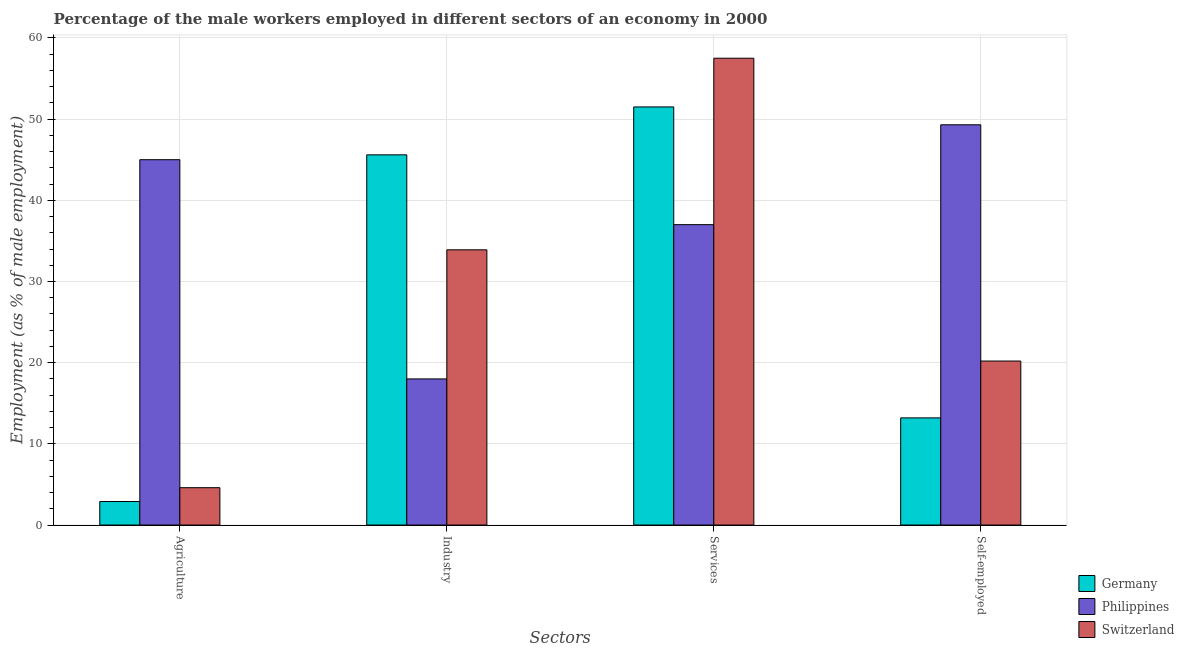How many different coloured bars are there?
Offer a terse response. 3. How many groups of bars are there?
Make the answer very short. 4. Are the number of bars per tick equal to the number of legend labels?
Your answer should be very brief. Yes. Are the number of bars on each tick of the X-axis equal?
Provide a short and direct response. Yes. How many bars are there on the 4th tick from the right?
Keep it short and to the point. 3. What is the label of the 2nd group of bars from the left?
Offer a very short reply. Industry. What is the percentage of male workers in services in Switzerland?
Your response must be concise. 57.5. Across all countries, what is the maximum percentage of male workers in industry?
Your response must be concise. 45.6. Across all countries, what is the minimum percentage of male workers in agriculture?
Offer a terse response. 2.9. In which country was the percentage of male workers in services maximum?
Your response must be concise. Switzerland. What is the total percentage of self employed male workers in the graph?
Offer a very short reply. 82.7. What is the difference between the percentage of male workers in agriculture in Germany and that in Philippines?
Give a very brief answer. -42.1. What is the difference between the percentage of male workers in industry in Germany and the percentage of self employed male workers in Philippines?
Your answer should be compact. -3.7. What is the ratio of the percentage of male workers in agriculture in Germany to that in Philippines?
Offer a very short reply. 0.06. What is the difference between the highest and the second highest percentage of male workers in agriculture?
Give a very brief answer. 40.4. What is the difference between the highest and the lowest percentage of male workers in industry?
Offer a terse response. 27.6. What does the 3rd bar from the left in Services represents?
Ensure brevity in your answer.  Switzerland. What does the 1st bar from the right in Industry represents?
Give a very brief answer. Switzerland. Is it the case that in every country, the sum of the percentage of male workers in agriculture and percentage of male workers in industry is greater than the percentage of male workers in services?
Provide a short and direct response. No. How many bars are there?
Offer a terse response. 12. Are all the bars in the graph horizontal?
Provide a short and direct response. No. How many countries are there in the graph?
Give a very brief answer. 3. What is the difference between two consecutive major ticks on the Y-axis?
Give a very brief answer. 10. Are the values on the major ticks of Y-axis written in scientific E-notation?
Keep it short and to the point. No. How many legend labels are there?
Make the answer very short. 3. How are the legend labels stacked?
Ensure brevity in your answer.  Vertical. What is the title of the graph?
Your answer should be very brief. Percentage of the male workers employed in different sectors of an economy in 2000. What is the label or title of the X-axis?
Your answer should be very brief. Sectors. What is the label or title of the Y-axis?
Make the answer very short. Employment (as % of male employment). What is the Employment (as % of male employment) of Germany in Agriculture?
Offer a terse response. 2.9. What is the Employment (as % of male employment) of Philippines in Agriculture?
Your response must be concise. 45. What is the Employment (as % of male employment) of Switzerland in Agriculture?
Offer a very short reply. 4.6. What is the Employment (as % of male employment) of Germany in Industry?
Make the answer very short. 45.6. What is the Employment (as % of male employment) in Philippines in Industry?
Offer a terse response. 18. What is the Employment (as % of male employment) in Switzerland in Industry?
Offer a very short reply. 33.9. What is the Employment (as % of male employment) of Germany in Services?
Provide a succinct answer. 51.5. What is the Employment (as % of male employment) of Philippines in Services?
Give a very brief answer. 37. What is the Employment (as % of male employment) in Switzerland in Services?
Give a very brief answer. 57.5. What is the Employment (as % of male employment) of Germany in Self-employed?
Your response must be concise. 13.2. What is the Employment (as % of male employment) in Philippines in Self-employed?
Your answer should be compact. 49.3. What is the Employment (as % of male employment) of Switzerland in Self-employed?
Ensure brevity in your answer.  20.2. Across all Sectors, what is the maximum Employment (as % of male employment) in Germany?
Offer a terse response. 51.5. Across all Sectors, what is the maximum Employment (as % of male employment) in Philippines?
Offer a very short reply. 49.3. Across all Sectors, what is the maximum Employment (as % of male employment) of Switzerland?
Make the answer very short. 57.5. Across all Sectors, what is the minimum Employment (as % of male employment) of Germany?
Offer a terse response. 2.9. Across all Sectors, what is the minimum Employment (as % of male employment) of Philippines?
Your answer should be compact. 18. Across all Sectors, what is the minimum Employment (as % of male employment) in Switzerland?
Your response must be concise. 4.6. What is the total Employment (as % of male employment) in Germany in the graph?
Keep it short and to the point. 113.2. What is the total Employment (as % of male employment) of Philippines in the graph?
Provide a succinct answer. 149.3. What is the total Employment (as % of male employment) in Switzerland in the graph?
Your answer should be compact. 116.2. What is the difference between the Employment (as % of male employment) in Germany in Agriculture and that in Industry?
Provide a succinct answer. -42.7. What is the difference between the Employment (as % of male employment) in Philippines in Agriculture and that in Industry?
Offer a terse response. 27. What is the difference between the Employment (as % of male employment) of Switzerland in Agriculture and that in Industry?
Your answer should be compact. -29.3. What is the difference between the Employment (as % of male employment) in Germany in Agriculture and that in Services?
Make the answer very short. -48.6. What is the difference between the Employment (as % of male employment) in Philippines in Agriculture and that in Services?
Give a very brief answer. 8. What is the difference between the Employment (as % of male employment) of Switzerland in Agriculture and that in Services?
Your answer should be compact. -52.9. What is the difference between the Employment (as % of male employment) of Germany in Agriculture and that in Self-employed?
Offer a very short reply. -10.3. What is the difference between the Employment (as % of male employment) in Philippines in Agriculture and that in Self-employed?
Keep it short and to the point. -4.3. What is the difference between the Employment (as % of male employment) in Switzerland in Agriculture and that in Self-employed?
Keep it short and to the point. -15.6. What is the difference between the Employment (as % of male employment) of Switzerland in Industry and that in Services?
Keep it short and to the point. -23.6. What is the difference between the Employment (as % of male employment) in Germany in Industry and that in Self-employed?
Your answer should be very brief. 32.4. What is the difference between the Employment (as % of male employment) in Philippines in Industry and that in Self-employed?
Provide a succinct answer. -31.3. What is the difference between the Employment (as % of male employment) of Switzerland in Industry and that in Self-employed?
Make the answer very short. 13.7. What is the difference between the Employment (as % of male employment) in Germany in Services and that in Self-employed?
Provide a short and direct response. 38.3. What is the difference between the Employment (as % of male employment) in Philippines in Services and that in Self-employed?
Your answer should be very brief. -12.3. What is the difference between the Employment (as % of male employment) in Switzerland in Services and that in Self-employed?
Give a very brief answer. 37.3. What is the difference between the Employment (as % of male employment) of Germany in Agriculture and the Employment (as % of male employment) of Philippines in Industry?
Provide a short and direct response. -15.1. What is the difference between the Employment (as % of male employment) of Germany in Agriculture and the Employment (as % of male employment) of Switzerland in Industry?
Keep it short and to the point. -31. What is the difference between the Employment (as % of male employment) in Germany in Agriculture and the Employment (as % of male employment) in Philippines in Services?
Keep it short and to the point. -34.1. What is the difference between the Employment (as % of male employment) in Germany in Agriculture and the Employment (as % of male employment) in Switzerland in Services?
Ensure brevity in your answer.  -54.6. What is the difference between the Employment (as % of male employment) in Philippines in Agriculture and the Employment (as % of male employment) in Switzerland in Services?
Your answer should be compact. -12.5. What is the difference between the Employment (as % of male employment) of Germany in Agriculture and the Employment (as % of male employment) of Philippines in Self-employed?
Ensure brevity in your answer.  -46.4. What is the difference between the Employment (as % of male employment) of Germany in Agriculture and the Employment (as % of male employment) of Switzerland in Self-employed?
Your answer should be compact. -17.3. What is the difference between the Employment (as % of male employment) of Philippines in Agriculture and the Employment (as % of male employment) of Switzerland in Self-employed?
Provide a succinct answer. 24.8. What is the difference between the Employment (as % of male employment) in Germany in Industry and the Employment (as % of male employment) in Philippines in Services?
Your answer should be very brief. 8.6. What is the difference between the Employment (as % of male employment) in Philippines in Industry and the Employment (as % of male employment) in Switzerland in Services?
Give a very brief answer. -39.5. What is the difference between the Employment (as % of male employment) of Germany in Industry and the Employment (as % of male employment) of Switzerland in Self-employed?
Keep it short and to the point. 25.4. What is the difference between the Employment (as % of male employment) of Philippines in Industry and the Employment (as % of male employment) of Switzerland in Self-employed?
Offer a terse response. -2.2. What is the difference between the Employment (as % of male employment) in Germany in Services and the Employment (as % of male employment) in Philippines in Self-employed?
Ensure brevity in your answer.  2.2. What is the difference between the Employment (as % of male employment) in Germany in Services and the Employment (as % of male employment) in Switzerland in Self-employed?
Keep it short and to the point. 31.3. What is the average Employment (as % of male employment) in Germany per Sectors?
Your answer should be very brief. 28.3. What is the average Employment (as % of male employment) in Philippines per Sectors?
Give a very brief answer. 37.33. What is the average Employment (as % of male employment) of Switzerland per Sectors?
Make the answer very short. 29.05. What is the difference between the Employment (as % of male employment) in Germany and Employment (as % of male employment) in Philippines in Agriculture?
Make the answer very short. -42.1. What is the difference between the Employment (as % of male employment) in Philippines and Employment (as % of male employment) in Switzerland in Agriculture?
Your answer should be compact. 40.4. What is the difference between the Employment (as % of male employment) in Germany and Employment (as % of male employment) in Philippines in Industry?
Give a very brief answer. 27.6. What is the difference between the Employment (as % of male employment) of Philippines and Employment (as % of male employment) of Switzerland in Industry?
Offer a very short reply. -15.9. What is the difference between the Employment (as % of male employment) of Germany and Employment (as % of male employment) of Philippines in Services?
Offer a terse response. 14.5. What is the difference between the Employment (as % of male employment) in Philippines and Employment (as % of male employment) in Switzerland in Services?
Your response must be concise. -20.5. What is the difference between the Employment (as % of male employment) in Germany and Employment (as % of male employment) in Philippines in Self-employed?
Your response must be concise. -36.1. What is the difference between the Employment (as % of male employment) in Germany and Employment (as % of male employment) in Switzerland in Self-employed?
Provide a short and direct response. -7. What is the difference between the Employment (as % of male employment) in Philippines and Employment (as % of male employment) in Switzerland in Self-employed?
Offer a terse response. 29.1. What is the ratio of the Employment (as % of male employment) of Germany in Agriculture to that in Industry?
Make the answer very short. 0.06. What is the ratio of the Employment (as % of male employment) of Switzerland in Agriculture to that in Industry?
Offer a very short reply. 0.14. What is the ratio of the Employment (as % of male employment) of Germany in Agriculture to that in Services?
Make the answer very short. 0.06. What is the ratio of the Employment (as % of male employment) in Philippines in Agriculture to that in Services?
Your answer should be compact. 1.22. What is the ratio of the Employment (as % of male employment) of Germany in Agriculture to that in Self-employed?
Keep it short and to the point. 0.22. What is the ratio of the Employment (as % of male employment) of Philippines in Agriculture to that in Self-employed?
Ensure brevity in your answer.  0.91. What is the ratio of the Employment (as % of male employment) in Switzerland in Agriculture to that in Self-employed?
Keep it short and to the point. 0.23. What is the ratio of the Employment (as % of male employment) in Germany in Industry to that in Services?
Offer a very short reply. 0.89. What is the ratio of the Employment (as % of male employment) of Philippines in Industry to that in Services?
Your response must be concise. 0.49. What is the ratio of the Employment (as % of male employment) in Switzerland in Industry to that in Services?
Provide a short and direct response. 0.59. What is the ratio of the Employment (as % of male employment) of Germany in Industry to that in Self-employed?
Ensure brevity in your answer.  3.45. What is the ratio of the Employment (as % of male employment) in Philippines in Industry to that in Self-employed?
Offer a terse response. 0.37. What is the ratio of the Employment (as % of male employment) of Switzerland in Industry to that in Self-employed?
Offer a very short reply. 1.68. What is the ratio of the Employment (as % of male employment) in Germany in Services to that in Self-employed?
Give a very brief answer. 3.9. What is the ratio of the Employment (as % of male employment) of Philippines in Services to that in Self-employed?
Your answer should be compact. 0.75. What is the ratio of the Employment (as % of male employment) in Switzerland in Services to that in Self-employed?
Your answer should be compact. 2.85. What is the difference between the highest and the second highest Employment (as % of male employment) of Philippines?
Your response must be concise. 4.3. What is the difference between the highest and the second highest Employment (as % of male employment) in Switzerland?
Provide a succinct answer. 23.6. What is the difference between the highest and the lowest Employment (as % of male employment) in Germany?
Your answer should be compact. 48.6. What is the difference between the highest and the lowest Employment (as % of male employment) in Philippines?
Offer a very short reply. 31.3. What is the difference between the highest and the lowest Employment (as % of male employment) of Switzerland?
Your response must be concise. 52.9. 